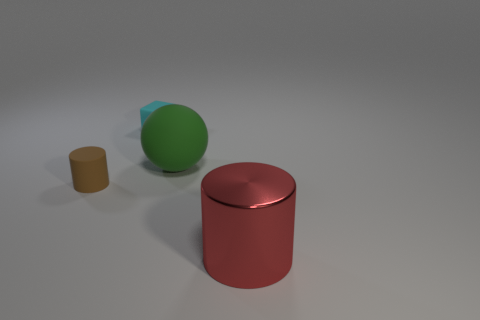Add 1 green spheres. How many objects exist? 5 Subtract all spheres. How many objects are left? 3 Subtract all tiny red rubber cylinders. Subtract all brown matte things. How many objects are left? 3 Add 2 green things. How many green things are left? 3 Add 1 metallic cylinders. How many metallic cylinders exist? 2 Subtract 0 yellow balls. How many objects are left? 4 